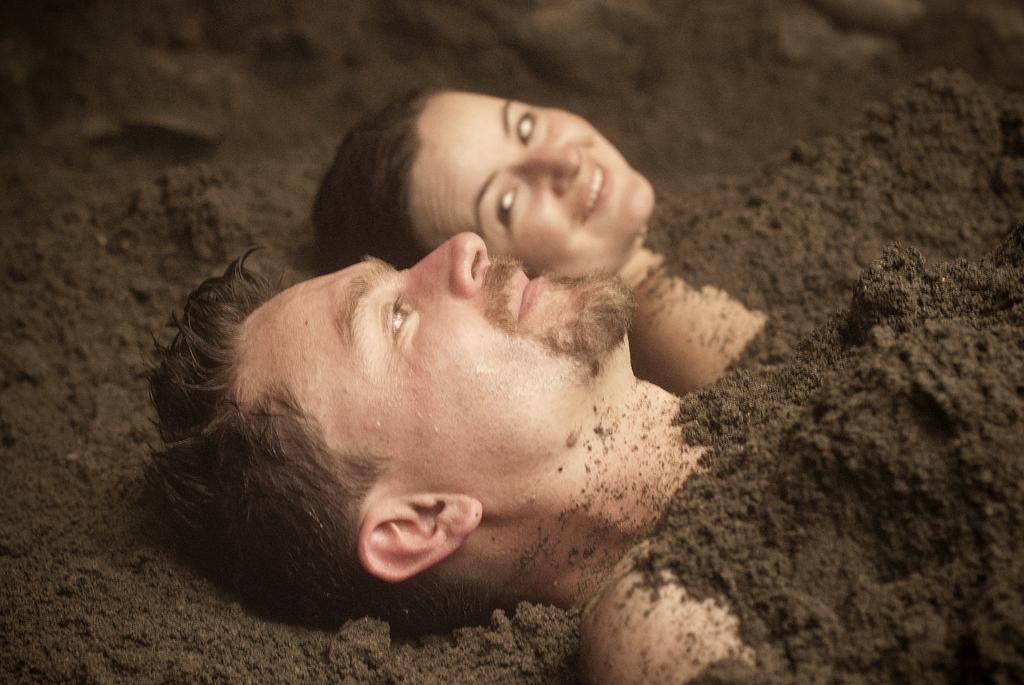Who are the people in the image? There is a man and a woman in the image. What are the man and woman doing in the image? Both the man and woman are lying on the ground. How are they positioned in the image? They are covered with soil. What is the woman's expression in the image? The woman is smiling. What type of art is the woman creating with the soil in the image? There is no indication in the image that the woman is creating any art with the soil. 